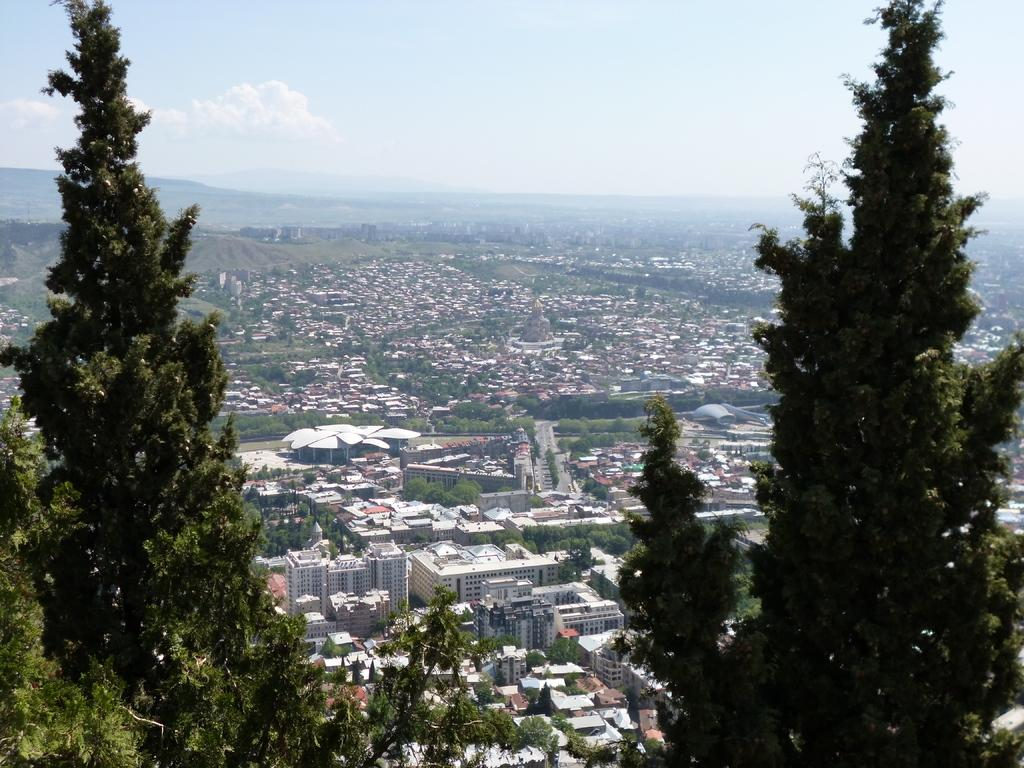What type of scene is depicted in the image? The image is a view of a city. What structures can be seen in the image? There are buildings in the image. Are there any natural elements present in the image? Yes, there are trees in the image. Can you describe the trees on the left side of the image? There are huge trees on the left side of the image. How about the trees on the right side of the image? There are also huge trees on the right side of the image. What can be seen in the background of the image? The sky is visible in the background of the image. Where is the store located in the image? There is no store present in the image. Can you see a snake slithering through the trees in the image? There is no snake present in the image. 